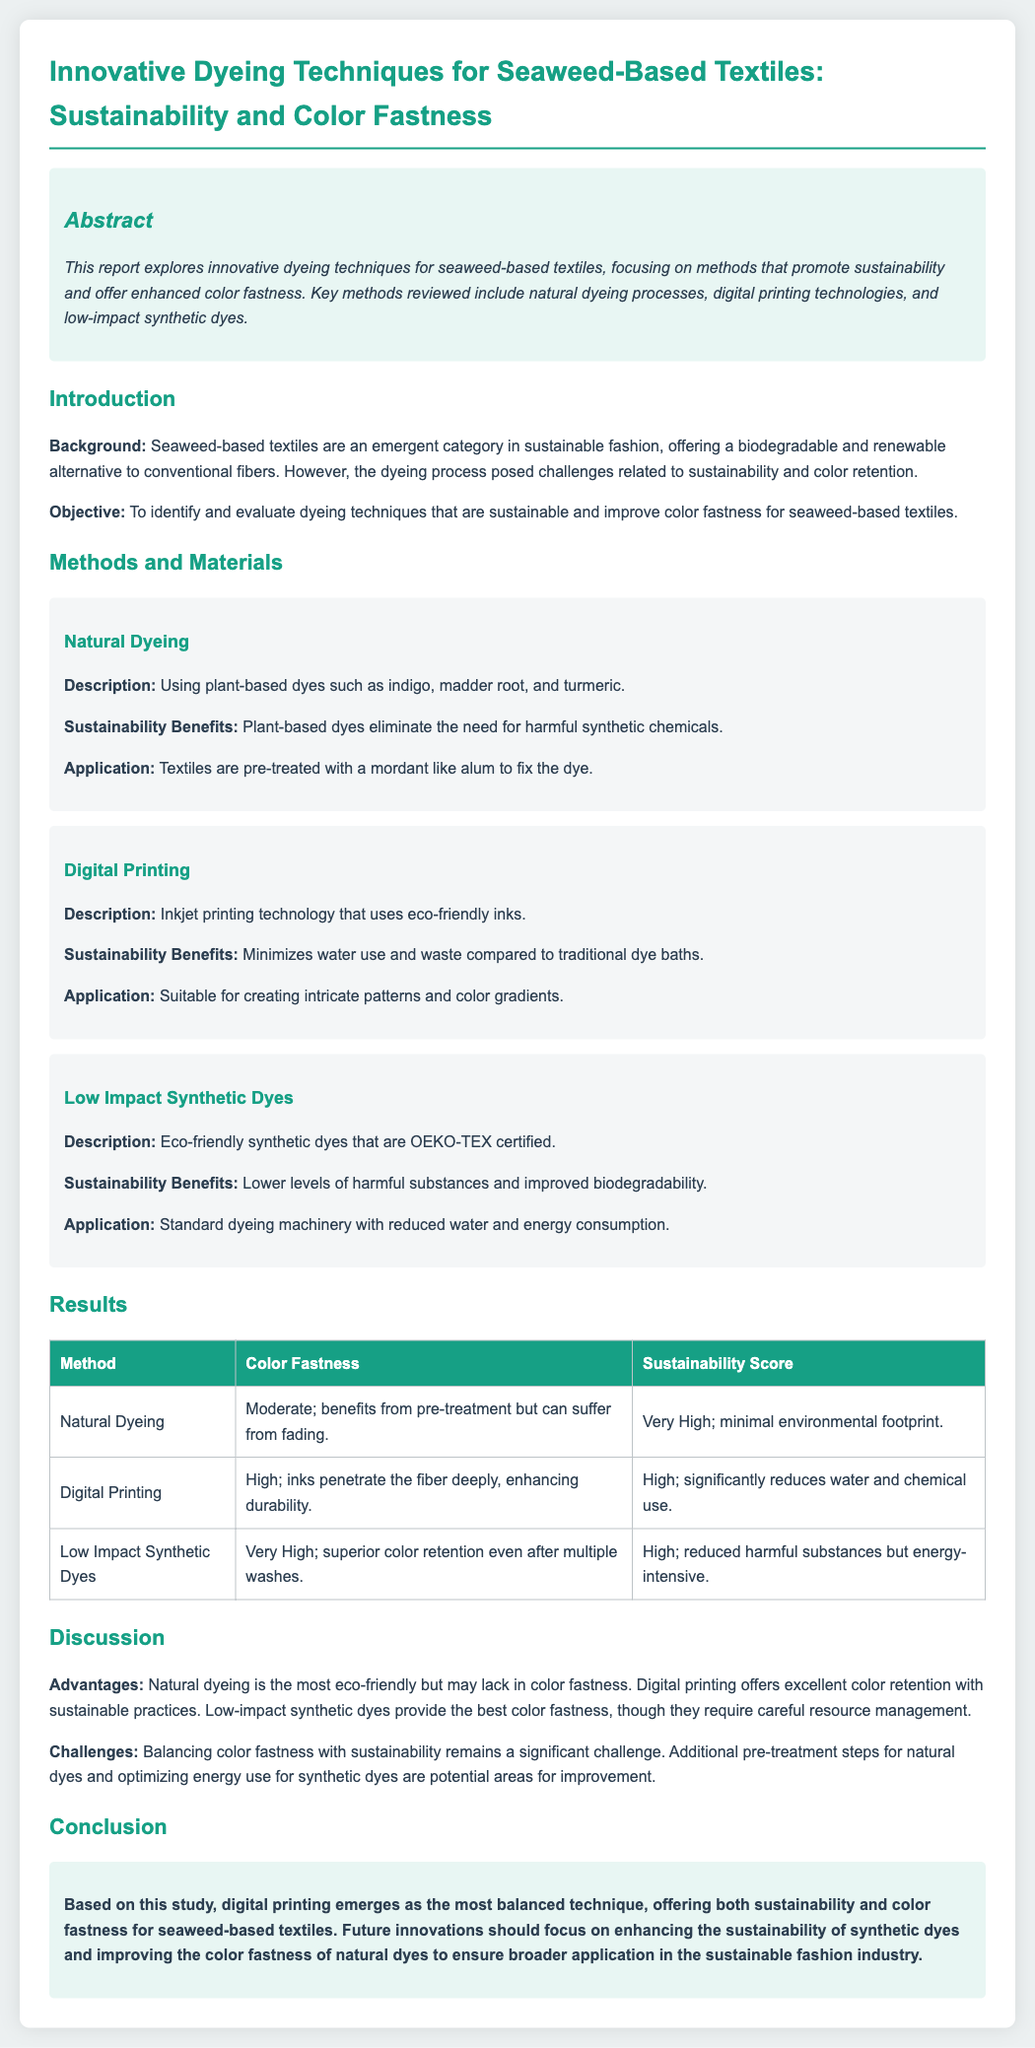what is the focus of the report? The report focuses on dyeing techniques that promote sustainability and offer enhanced color fastness for seaweed-based textiles.
Answer: sustainability and color fastness which natural dyes are mentioned? The report mentions indigo, madder root, and turmeric as natural dyes used.
Answer: indigo, madder root, turmeric what is the color fastness rating for digital printing? The color fastness rating for digital printing is high, indicating durability.
Answer: High what is the sustainability score for low impact synthetic dyes? The sustainability score for low impact synthetic dyes is high, reflecting reduced harmful substances.
Answer: High which dyeing method requires a mordant? Natural dyeing requires a mordant like alum to fix the dye.
Answer: Natural dyeing what challenge is highlighted in the discussion section? The challenge highlighted is balancing color fastness with sustainability.
Answer: balancing color fastness with sustainability how does digital printing compare to natural dyeing regarding color fastness? Digital printing offers excellent color retention compared to natural dyeing, which may lack this attribute.
Answer: better color retention which dyeing technique has very high sustainability benefits? Natural dyeing has very high sustainability benefits due to its minimal environmental footprint.
Answer: Natural Dyeing 